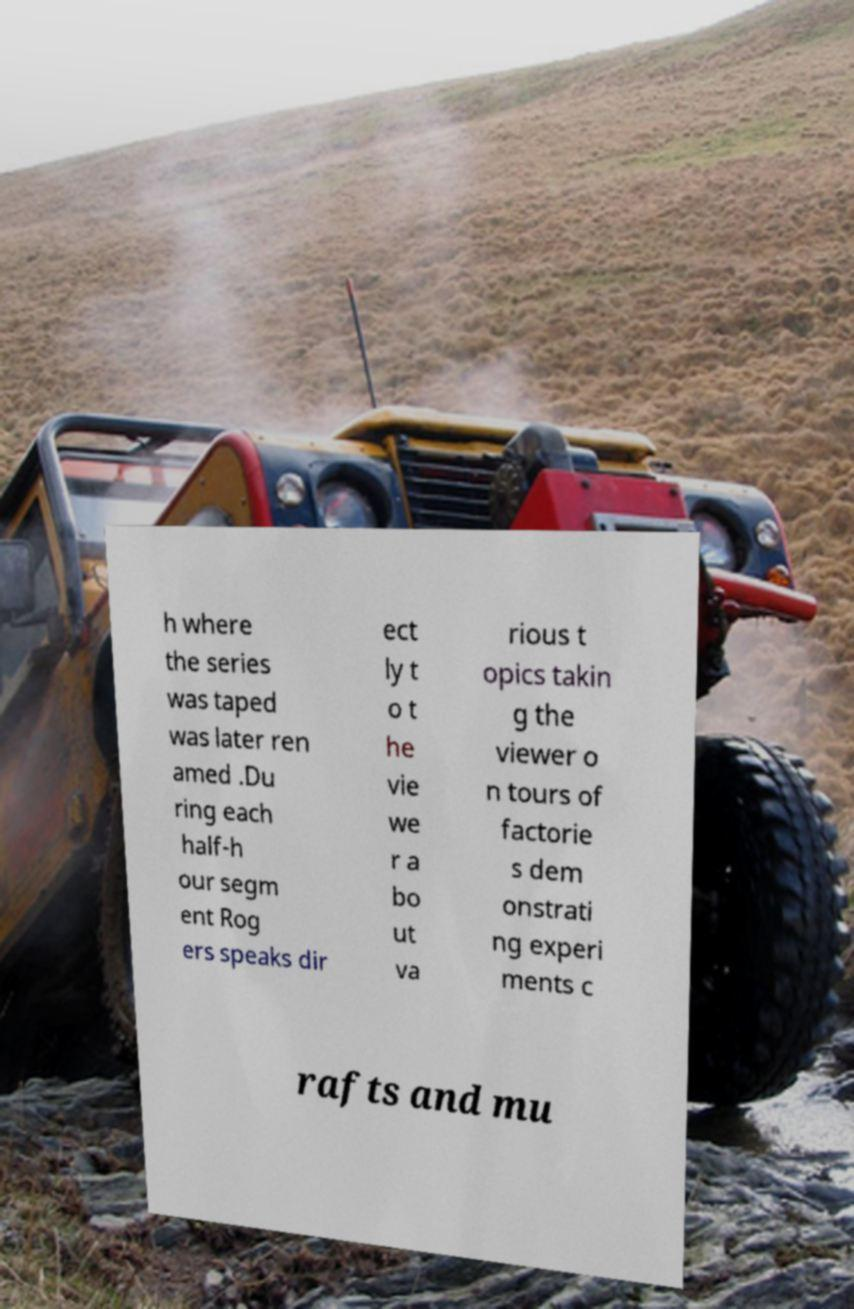Please identify and transcribe the text found in this image. h where the series was taped was later ren amed .Du ring each half-h our segm ent Rog ers speaks dir ect ly t o t he vie we r a bo ut va rious t opics takin g the viewer o n tours of factorie s dem onstrati ng experi ments c rafts and mu 